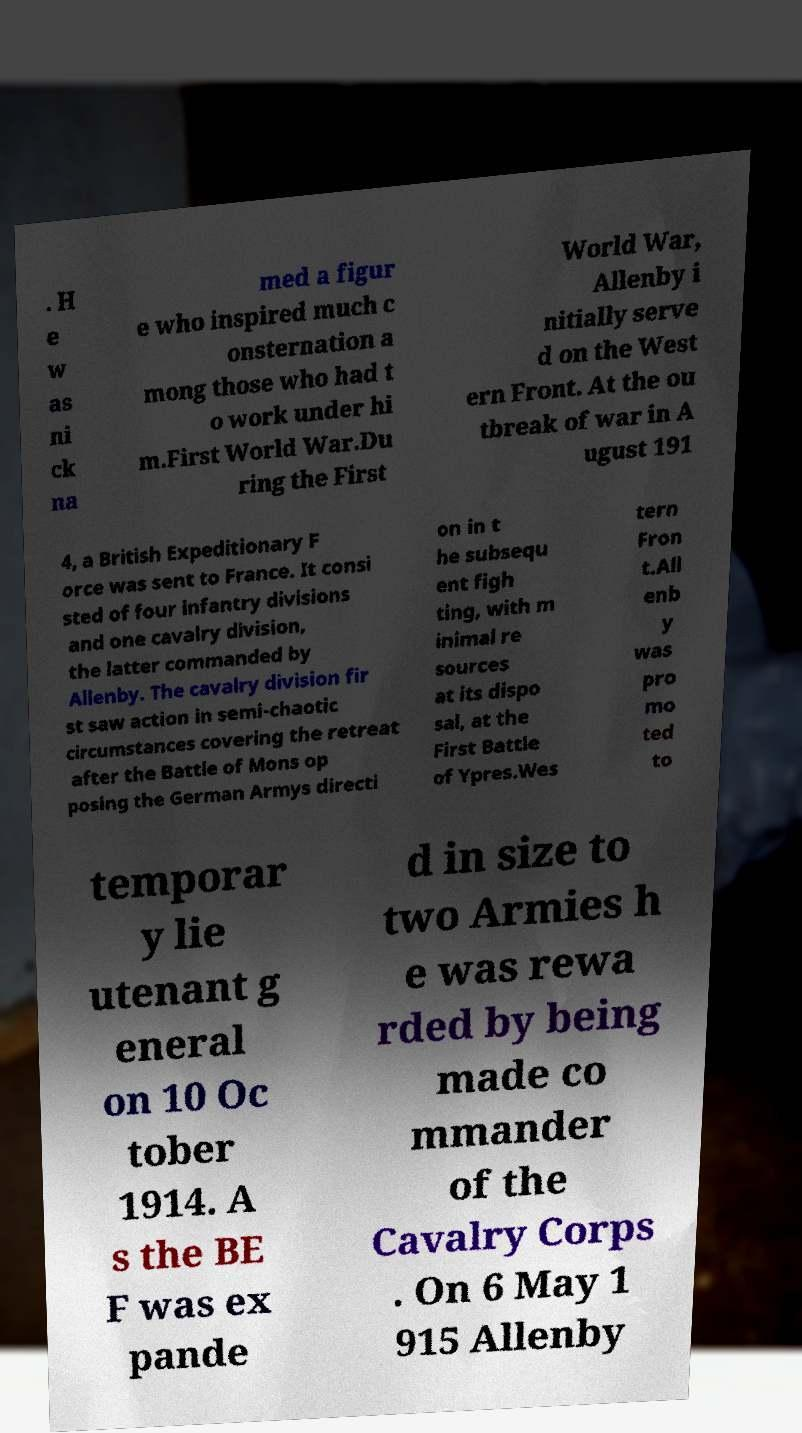Can you read and provide the text displayed in the image?This photo seems to have some interesting text. Can you extract and type it out for me? . H e w as ni ck na med a figur e who inspired much c onsternation a mong those who had t o work under hi m.First World War.Du ring the First World War, Allenby i nitially serve d on the West ern Front. At the ou tbreak of war in A ugust 191 4, a British Expeditionary F orce was sent to France. It consi sted of four infantry divisions and one cavalry division, the latter commanded by Allenby. The cavalry division fir st saw action in semi-chaotic circumstances covering the retreat after the Battle of Mons op posing the German Armys directi on in t he subsequ ent figh ting, with m inimal re sources at its dispo sal, at the First Battle of Ypres.Wes tern Fron t.All enb y was pro mo ted to temporar y lie utenant g eneral on 10 Oc tober 1914. A s the BE F was ex pande d in size to two Armies h e was rewa rded by being made co mmander of the Cavalry Corps . On 6 May 1 915 Allenby 